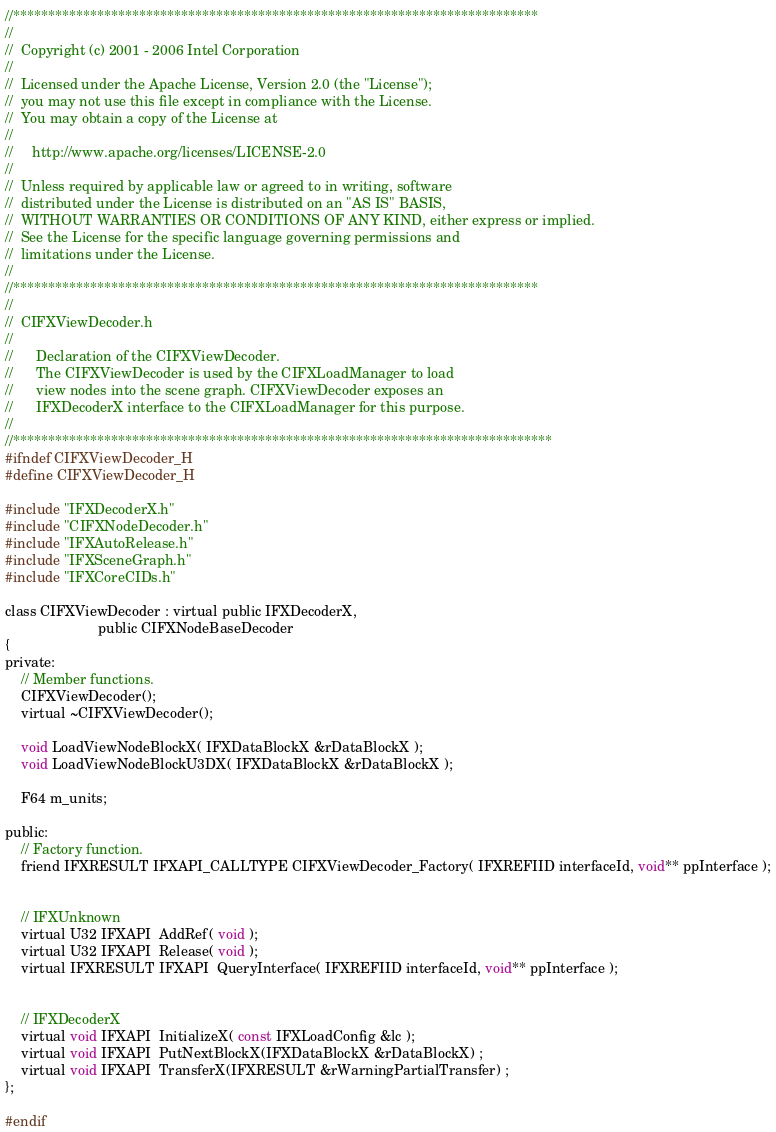Convert code to text. <code><loc_0><loc_0><loc_500><loc_500><_C_>//***************************************************************************
//
//  Copyright (c) 2001 - 2006 Intel Corporation
//
//  Licensed under the Apache License, Version 2.0 (the "License");
//  you may not use this file except in compliance with the License.
//  You may obtain a copy of the License at
//
//     http://www.apache.org/licenses/LICENSE-2.0
//
//  Unless required by applicable law or agreed to in writing, software
//  distributed under the License is distributed on an "AS IS" BASIS,
//  WITHOUT WARRANTIES OR CONDITIONS OF ANY KIND, either express or implied.
//  See the License for the specific language governing permissions and
//  limitations under the License.
//
//***************************************************************************
//
//	CIFXViewDecoder.h
//
//		Declaration of the CIFXViewDecoder.
//		The CIFXViewDecoder is used by the CIFXLoadManager to load
//		view nodes into the scene graph. CIFXViewDecoder exposes an
//		IFXDecoderX interface to the CIFXLoadManager for this purpose.
//
//*****************************************************************************
#ifndef CIFXViewDecoder_H
#define CIFXViewDecoder_H

#include "IFXDecoderX.h"
#include "CIFXNodeDecoder.h"
#include "IFXAutoRelease.h"
#include "IFXSceneGraph.h"
#include "IFXCoreCIDs.h"

class CIFXViewDecoder : virtual public IFXDecoderX,
					    public CIFXNodeBaseDecoder
{
private:
	// Member functions.
    CIFXViewDecoder();
	virtual ~CIFXViewDecoder();

	void LoadViewNodeBlockX( IFXDataBlockX &rDataBlockX );
	void LoadViewNodeBlockU3DX( IFXDataBlockX &rDataBlockX );

	F64 m_units;

public:
	// Factory function.
	friend IFXRESULT IFXAPI_CALLTYPE CIFXViewDecoder_Factory( IFXREFIID interfaceId, void** ppInterface );

	
	// IFXUnknown
	virtual U32 IFXAPI  AddRef( void );
	virtual U32 IFXAPI  Release( void );
	virtual IFXRESULT IFXAPI  QueryInterface( IFXREFIID interfaceId, void** ppInterface );

	
	// IFXDecoderX
	virtual void IFXAPI  InitializeX( const IFXLoadConfig &lc );
	virtual void IFXAPI  PutNextBlockX(IFXDataBlockX &rDataBlockX) ;
	virtual void IFXAPI  TransferX(IFXRESULT &rWarningPartialTransfer) ;
};

#endif
</code> 